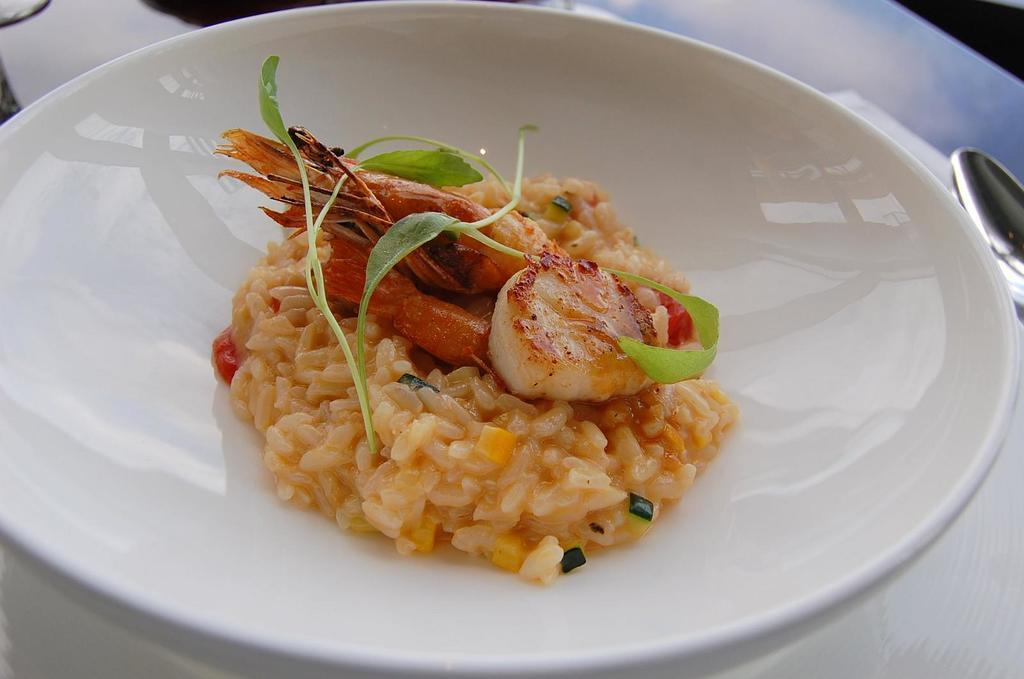What is present on the plate in the image? There is food on the plate in the image. What utensil is located beside the plate? There is a spoon beside the plate in the image. How does the writer feel about the food on the plate in the image? There is no writer present in the image, so it is not possible to determine their feelings about the food. 